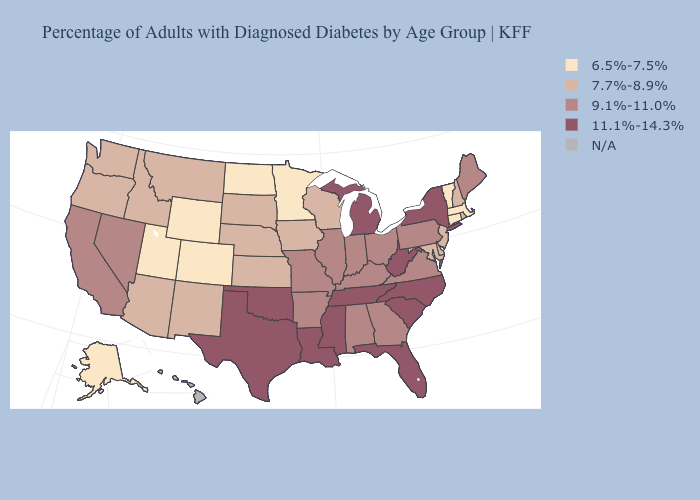Does the first symbol in the legend represent the smallest category?
Concise answer only. Yes. Is the legend a continuous bar?
Keep it brief. No. Name the states that have a value in the range N/A?
Quick response, please. Hawaii. Does Oklahoma have the highest value in the USA?
Be succinct. Yes. Is the legend a continuous bar?
Answer briefly. No. Name the states that have a value in the range 11.1%-14.3%?
Be succinct. Florida, Louisiana, Michigan, Mississippi, New York, North Carolina, Oklahoma, South Carolina, Tennessee, Texas, West Virginia. Which states have the highest value in the USA?
Quick response, please. Florida, Louisiana, Michigan, Mississippi, New York, North Carolina, Oklahoma, South Carolina, Tennessee, Texas, West Virginia. What is the value of Oklahoma?
Answer briefly. 11.1%-14.3%. What is the value of New Jersey?
Write a very short answer. 7.7%-8.9%. Which states have the lowest value in the USA?
Quick response, please. Alaska, Colorado, Connecticut, Massachusetts, Minnesota, North Dakota, Utah, Vermont, Wyoming. Is the legend a continuous bar?
Concise answer only. No. Which states have the lowest value in the MidWest?
Quick response, please. Minnesota, North Dakota. What is the value of North Dakota?
Keep it brief. 6.5%-7.5%. 